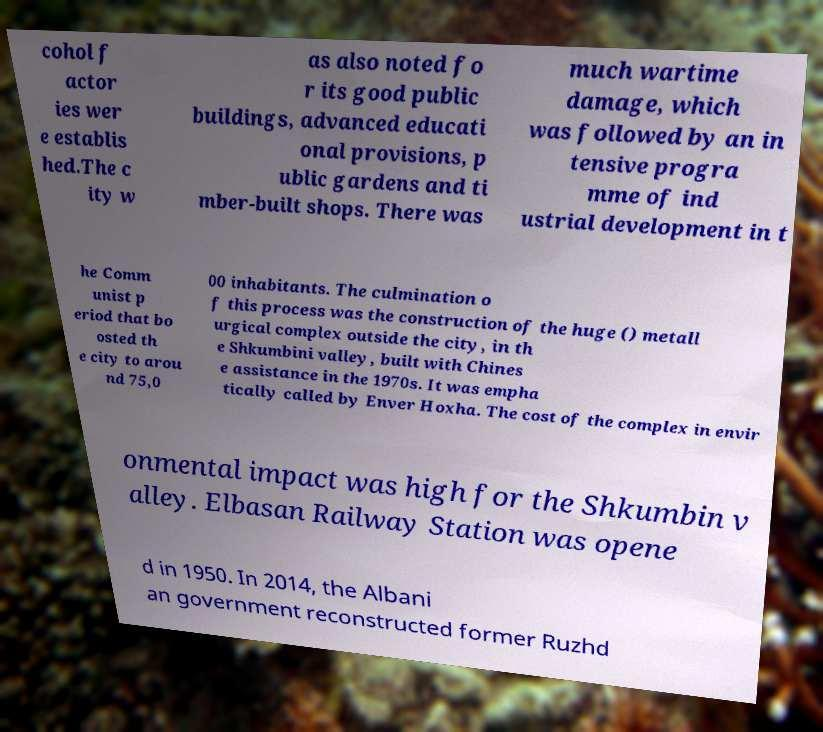Could you extract and type out the text from this image? cohol f actor ies wer e establis hed.The c ity w as also noted fo r its good public buildings, advanced educati onal provisions, p ublic gardens and ti mber-built shops. There was much wartime damage, which was followed by an in tensive progra mme of ind ustrial development in t he Comm unist p eriod that bo osted th e city to arou nd 75,0 00 inhabitants. The culmination o f this process was the construction of the huge () metall urgical complex outside the city, in th e Shkumbini valley, built with Chines e assistance in the 1970s. It was empha tically called by Enver Hoxha. The cost of the complex in envir onmental impact was high for the Shkumbin v alley. Elbasan Railway Station was opene d in 1950. In 2014, the Albani an government reconstructed former Ruzhd 